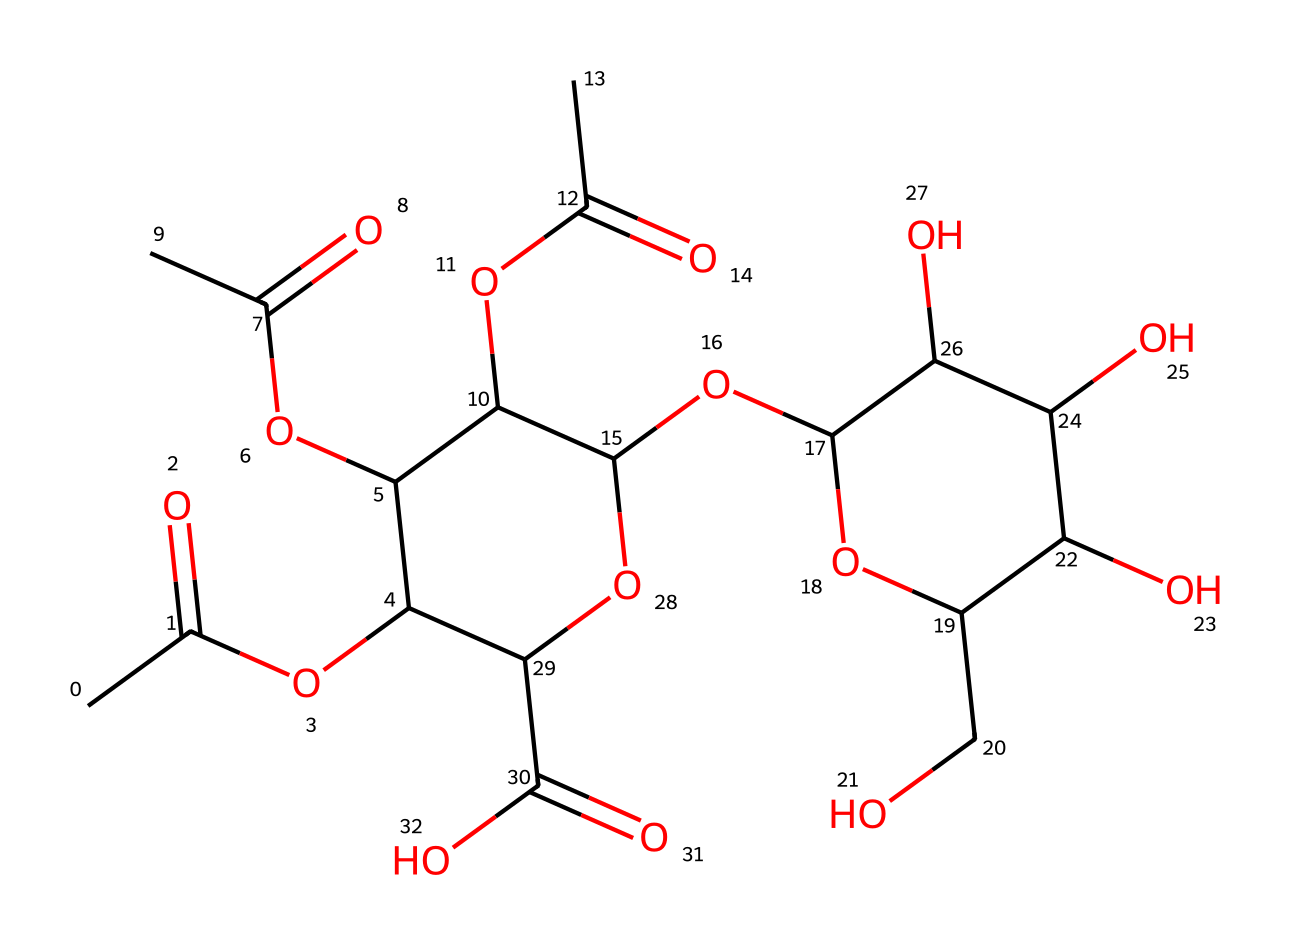How many different types of atoms are present in this chemical structure? The SMILES representation reveals the presence of carbon (C), hydrogen (H), and oxygen (O) atoms. By counting each type of atom in the molecular structure, we find carbon has a total of 16, hydrogen has 30, and oxygen has 8. Thus, there are three types of atoms: carbon, hydrogen, and oxygen.
Answer: three What functional groups can be identified in this pectin molecule? Analyzing the structure, we observe carboxylic acid (-COOH) and ester (-COO-) functional groups. The presence of these groups can be determined by looking at the specific arrangements of atoms, such as the carbonyl (C=O) and hydroxyl (-OH) components in the structure.
Answer: carboxylic acid and ester How many ester linkages are present in the molecular structure? Esters are formed from the reaction between an alcohol and a carboxylic acid. In this structure, we identify several ester linkages by recognizing the -COO- connections between different sugars, indicating how they are bonded. Upon closer inspection, we can see 4 such ester linkages throughout the structure.
Answer: four What is the primary type of polymer that pectin represents? Pectin is primarily categorized as a polysaccharide, which is a long carbohydrate molecule composed of numerous monosaccharide units linked by glycosidic bonds. By recognizing the repeating sugar units and their structure, we confirm that pectin fits into this category.
Answer: polysaccharide Does the structure indicate any regions of branching? Yes, upon examining the molecular structure, we can identify branching due to the presence of multiple branching points where the sugar units connect at angles rather than in a linear formation. This branching is characteristic of the polysaccharide nature of pectin.
Answer: yes What role does pectin play in fruit preserves? Pectin acts as a gelling agent in fruit preserves, which can be inferred from its ability to form gels due to the molecular arrangement of its chains and functional groups that interact with water and sugar. This capability to gel is key for the texture of fruit preserves.
Answer: gelling agent 